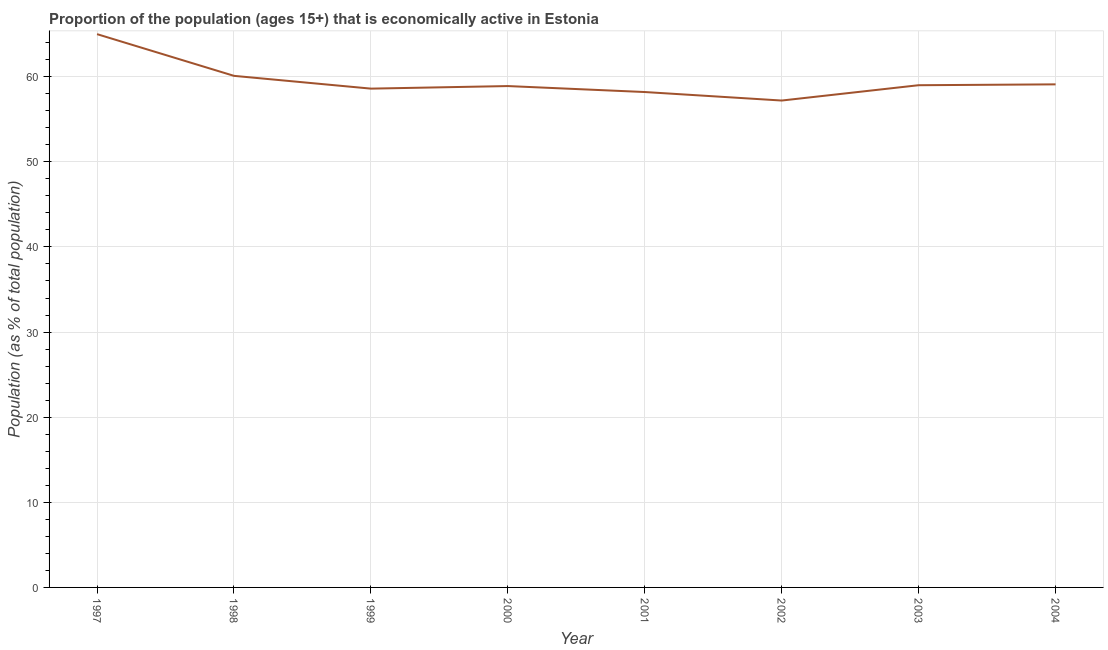What is the percentage of economically active population in 2001?
Provide a succinct answer. 58.2. Across all years, what is the maximum percentage of economically active population?
Give a very brief answer. 65. Across all years, what is the minimum percentage of economically active population?
Your response must be concise. 57.2. In which year was the percentage of economically active population maximum?
Ensure brevity in your answer.  1997. What is the sum of the percentage of economically active population?
Give a very brief answer. 476.1. What is the difference between the percentage of economically active population in 1999 and 2000?
Give a very brief answer. -0.3. What is the average percentage of economically active population per year?
Give a very brief answer. 59.51. What is the median percentage of economically active population?
Make the answer very short. 58.95. In how many years, is the percentage of economically active population greater than 28 %?
Keep it short and to the point. 8. What is the ratio of the percentage of economically active population in 1999 to that in 2003?
Your answer should be compact. 0.99. Is the percentage of economically active population in 1998 less than that in 2001?
Provide a succinct answer. No. What is the difference between the highest and the second highest percentage of economically active population?
Keep it short and to the point. 4.9. What is the difference between the highest and the lowest percentage of economically active population?
Provide a short and direct response. 7.8. In how many years, is the percentage of economically active population greater than the average percentage of economically active population taken over all years?
Provide a short and direct response. 2. Are the values on the major ticks of Y-axis written in scientific E-notation?
Offer a very short reply. No. Does the graph contain grids?
Offer a very short reply. Yes. What is the title of the graph?
Offer a terse response. Proportion of the population (ages 15+) that is economically active in Estonia. What is the label or title of the Y-axis?
Provide a short and direct response. Population (as % of total population). What is the Population (as % of total population) in 1997?
Provide a short and direct response. 65. What is the Population (as % of total population) of 1998?
Provide a short and direct response. 60.1. What is the Population (as % of total population) of 1999?
Make the answer very short. 58.6. What is the Population (as % of total population) in 2000?
Offer a terse response. 58.9. What is the Population (as % of total population) in 2001?
Your answer should be very brief. 58.2. What is the Population (as % of total population) of 2002?
Offer a very short reply. 57.2. What is the Population (as % of total population) of 2003?
Provide a succinct answer. 59. What is the Population (as % of total population) in 2004?
Make the answer very short. 59.1. What is the difference between the Population (as % of total population) in 1997 and 1998?
Give a very brief answer. 4.9. What is the difference between the Population (as % of total population) in 1998 and 2000?
Make the answer very short. 1.2. What is the difference between the Population (as % of total population) in 1998 and 2003?
Your response must be concise. 1.1. What is the difference between the Population (as % of total population) in 1999 and 2001?
Give a very brief answer. 0.4. What is the difference between the Population (as % of total population) in 1999 and 2003?
Your answer should be very brief. -0.4. What is the difference between the Population (as % of total population) in 1999 and 2004?
Keep it short and to the point. -0.5. What is the difference between the Population (as % of total population) in 2000 and 2003?
Your response must be concise. -0.1. What is the difference between the Population (as % of total population) in 2000 and 2004?
Your answer should be compact. -0.2. What is the difference between the Population (as % of total population) in 2001 and 2004?
Offer a very short reply. -0.9. What is the difference between the Population (as % of total population) in 2003 and 2004?
Provide a succinct answer. -0.1. What is the ratio of the Population (as % of total population) in 1997 to that in 1998?
Your response must be concise. 1.08. What is the ratio of the Population (as % of total population) in 1997 to that in 1999?
Provide a short and direct response. 1.11. What is the ratio of the Population (as % of total population) in 1997 to that in 2000?
Ensure brevity in your answer.  1.1. What is the ratio of the Population (as % of total population) in 1997 to that in 2001?
Your answer should be very brief. 1.12. What is the ratio of the Population (as % of total population) in 1997 to that in 2002?
Ensure brevity in your answer.  1.14. What is the ratio of the Population (as % of total population) in 1997 to that in 2003?
Provide a short and direct response. 1.1. What is the ratio of the Population (as % of total population) in 1998 to that in 1999?
Keep it short and to the point. 1.03. What is the ratio of the Population (as % of total population) in 1998 to that in 2001?
Offer a very short reply. 1.03. What is the ratio of the Population (as % of total population) in 1998 to that in 2002?
Your answer should be very brief. 1.05. What is the ratio of the Population (as % of total population) in 1999 to that in 2001?
Offer a very short reply. 1.01. What is the ratio of the Population (as % of total population) in 2001 to that in 2003?
Make the answer very short. 0.99. What is the ratio of the Population (as % of total population) in 2001 to that in 2004?
Keep it short and to the point. 0.98. What is the ratio of the Population (as % of total population) in 2002 to that in 2004?
Your answer should be compact. 0.97. What is the ratio of the Population (as % of total population) in 2003 to that in 2004?
Give a very brief answer. 1. 